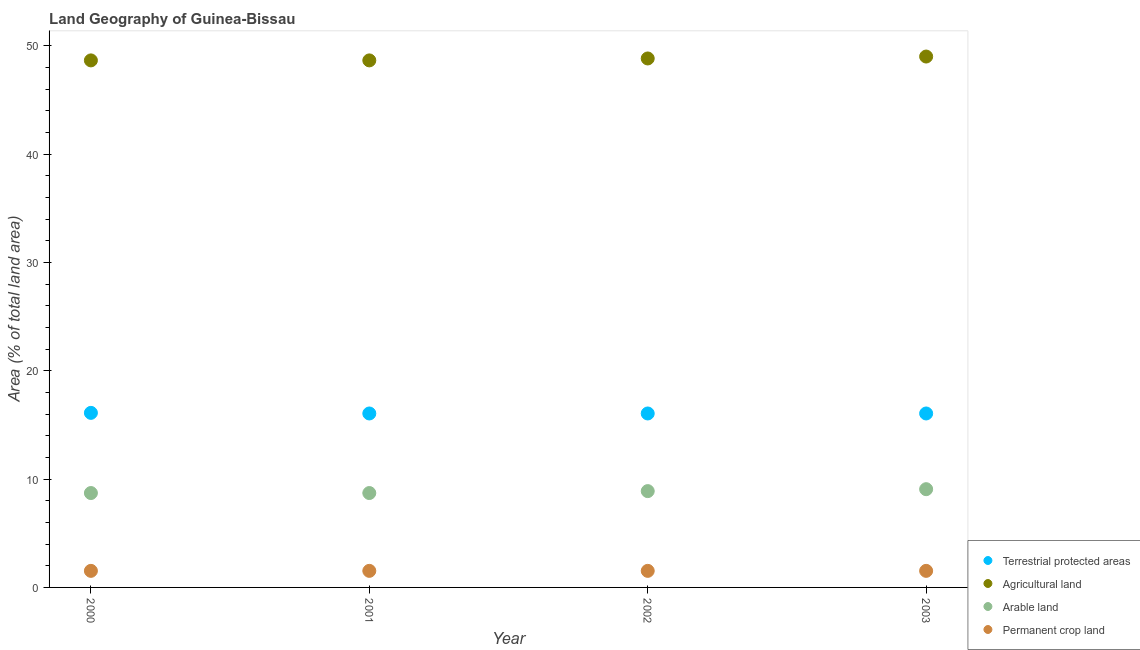How many different coloured dotlines are there?
Offer a very short reply. 4. Is the number of dotlines equal to the number of legend labels?
Provide a succinct answer. Yes. What is the percentage of area under agricultural land in 2001?
Provide a succinct answer. 48.65. Across all years, what is the maximum percentage of area under permanent crop land?
Your answer should be very brief. 1.53. Across all years, what is the minimum percentage of area under arable land?
Your answer should be very brief. 8.71. In which year was the percentage of area under arable land maximum?
Your answer should be very brief. 2003. What is the total percentage of area under permanent crop land in the graph?
Ensure brevity in your answer.  6.12. What is the difference between the percentage of area under arable land in 2001 and that in 2002?
Make the answer very short. -0.18. What is the difference between the percentage of land under terrestrial protection in 2001 and the percentage of area under agricultural land in 2000?
Your response must be concise. -32.59. What is the average percentage of land under terrestrial protection per year?
Offer a terse response. 16.07. In the year 2001, what is the difference between the percentage of area under arable land and percentage of land under terrestrial protection?
Provide a short and direct response. -7.34. In how many years, is the percentage of area under arable land greater than 34 %?
Offer a very short reply. 0. Is the percentage of area under agricultural land in 2000 less than that in 2001?
Ensure brevity in your answer.  No. What is the difference between the highest and the second highest percentage of area under agricultural land?
Provide a succinct answer. 0.18. What is the difference between the highest and the lowest percentage of land under terrestrial protection?
Provide a succinct answer. 0.06. Is it the case that in every year, the sum of the percentage of area under arable land and percentage of area under permanent crop land is greater than the sum of percentage of land under terrestrial protection and percentage of area under agricultural land?
Give a very brief answer. No. How many dotlines are there?
Ensure brevity in your answer.  4. Are the values on the major ticks of Y-axis written in scientific E-notation?
Ensure brevity in your answer.  No. Does the graph contain any zero values?
Give a very brief answer. No. How many legend labels are there?
Ensure brevity in your answer.  4. How are the legend labels stacked?
Your response must be concise. Vertical. What is the title of the graph?
Make the answer very short. Land Geography of Guinea-Bissau. Does "Taxes on exports" appear as one of the legend labels in the graph?
Provide a short and direct response. No. What is the label or title of the Y-axis?
Keep it short and to the point. Area (% of total land area). What is the Area (% of total land area) of Terrestrial protected areas in 2000?
Make the answer very short. 16.11. What is the Area (% of total land area) of Agricultural land in 2000?
Keep it short and to the point. 48.65. What is the Area (% of total land area) in Arable land in 2000?
Your answer should be very brief. 8.71. What is the Area (% of total land area) in Permanent crop land in 2000?
Your answer should be very brief. 1.53. What is the Area (% of total land area) in Terrestrial protected areas in 2001?
Offer a terse response. 16.06. What is the Area (% of total land area) of Agricultural land in 2001?
Ensure brevity in your answer.  48.65. What is the Area (% of total land area) in Arable land in 2001?
Your response must be concise. 8.71. What is the Area (% of total land area) in Permanent crop land in 2001?
Offer a very short reply. 1.53. What is the Area (% of total land area) of Terrestrial protected areas in 2002?
Offer a terse response. 16.06. What is the Area (% of total land area) of Agricultural land in 2002?
Your answer should be very brief. 48.83. What is the Area (% of total land area) in Arable land in 2002?
Ensure brevity in your answer.  8.89. What is the Area (% of total land area) of Permanent crop land in 2002?
Your answer should be very brief. 1.53. What is the Area (% of total land area) of Terrestrial protected areas in 2003?
Your response must be concise. 16.06. What is the Area (% of total land area) of Agricultural land in 2003?
Provide a short and direct response. 49. What is the Area (% of total land area) in Arable land in 2003?
Your response must be concise. 9.07. What is the Area (% of total land area) in Permanent crop land in 2003?
Keep it short and to the point. 1.53. Across all years, what is the maximum Area (% of total land area) of Terrestrial protected areas?
Keep it short and to the point. 16.11. Across all years, what is the maximum Area (% of total land area) of Agricultural land?
Make the answer very short. 49. Across all years, what is the maximum Area (% of total land area) in Arable land?
Offer a very short reply. 9.07. Across all years, what is the maximum Area (% of total land area) in Permanent crop land?
Give a very brief answer. 1.53. Across all years, what is the minimum Area (% of total land area) in Terrestrial protected areas?
Your answer should be compact. 16.06. Across all years, what is the minimum Area (% of total land area) in Agricultural land?
Keep it short and to the point. 48.65. Across all years, what is the minimum Area (% of total land area) of Arable land?
Keep it short and to the point. 8.71. Across all years, what is the minimum Area (% of total land area) of Permanent crop land?
Make the answer very short. 1.53. What is the total Area (% of total land area) in Terrestrial protected areas in the graph?
Make the answer very short. 64.28. What is the total Area (% of total land area) of Agricultural land in the graph?
Offer a terse response. 195.13. What is the total Area (% of total land area) of Arable land in the graph?
Your answer should be compact. 35.38. What is the total Area (% of total land area) of Permanent crop land in the graph?
Provide a short and direct response. 6.12. What is the difference between the Area (% of total land area) in Terrestrial protected areas in 2000 and that in 2001?
Offer a terse response. 0.06. What is the difference between the Area (% of total land area) of Agricultural land in 2000 and that in 2001?
Your answer should be compact. 0. What is the difference between the Area (% of total land area) in Arable land in 2000 and that in 2001?
Ensure brevity in your answer.  0. What is the difference between the Area (% of total land area) of Permanent crop land in 2000 and that in 2001?
Give a very brief answer. 0. What is the difference between the Area (% of total land area) in Terrestrial protected areas in 2000 and that in 2002?
Provide a succinct answer. 0.06. What is the difference between the Area (% of total land area) in Agricultural land in 2000 and that in 2002?
Provide a short and direct response. -0.18. What is the difference between the Area (% of total land area) in Arable land in 2000 and that in 2002?
Your answer should be very brief. -0.18. What is the difference between the Area (% of total land area) in Terrestrial protected areas in 2000 and that in 2003?
Your answer should be compact. 0.06. What is the difference between the Area (% of total land area) in Agricultural land in 2000 and that in 2003?
Give a very brief answer. -0.36. What is the difference between the Area (% of total land area) in Arable land in 2000 and that in 2003?
Give a very brief answer. -0.36. What is the difference between the Area (% of total land area) of Permanent crop land in 2000 and that in 2003?
Offer a terse response. 0. What is the difference between the Area (% of total land area) of Agricultural land in 2001 and that in 2002?
Offer a very short reply. -0.18. What is the difference between the Area (% of total land area) of Arable land in 2001 and that in 2002?
Give a very brief answer. -0.18. What is the difference between the Area (% of total land area) of Terrestrial protected areas in 2001 and that in 2003?
Offer a very short reply. 0. What is the difference between the Area (% of total land area) in Agricultural land in 2001 and that in 2003?
Make the answer very short. -0.36. What is the difference between the Area (% of total land area) of Arable land in 2001 and that in 2003?
Make the answer very short. -0.36. What is the difference between the Area (% of total land area) of Terrestrial protected areas in 2002 and that in 2003?
Your answer should be very brief. 0. What is the difference between the Area (% of total land area) of Agricultural land in 2002 and that in 2003?
Offer a terse response. -0.18. What is the difference between the Area (% of total land area) of Arable land in 2002 and that in 2003?
Make the answer very short. -0.18. What is the difference between the Area (% of total land area) in Terrestrial protected areas in 2000 and the Area (% of total land area) in Agricultural land in 2001?
Offer a terse response. -32.54. What is the difference between the Area (% of total land area) in Terrestrial protected areas in 2000 and the Area (% of total land area) in Arable land in 2001?
Offer a terse response. 7.4. What is the difference between the Area (% of total land area) in Terrestrial protected areas in 2000 and the Area (% of total land area) in Permanent crop land in 2001?
Offer a terse response. 14.58. What is the difference between the Area (% of total land area) of Agricultural land in 2000 and the Area (% of total land area) of Arable land in 2001?
Keep it short and to the point. 39.94. What is the difference between the Area (% of total land area) in Agricultural land in 2000 and the Area (% of total land area) in Permanent crop land in 2001?
Make the answer very short. 47.12. What is the difference between the Area (% of total land area) of Arable land in 2000 and the Area (% of total land area) of Permanent crop land in 2001?
Your answer should be compact. 7.18. What is the difference between the Area (% of total land area) of Terrestrial protected areas in 2000 and the Area (% of total land area) of Agricultural land in 2002?
Provide a short and direct response. -32.71. What is the difference between the Area (% of total land area) of Terrestrial protected areas in 2000 and the Area (% of total land area) of Arable land in 2002?
Provide a short and direct response. 7.22. What is the difference between the Area (% of total land area) of Terrestrial protected areas in 2000 and the Area (% of total land area) of Permanent crop land in 2002?
Offer a terse response. 14.58. What is the difference between the Area (% of total land area) of Agricultural land in 2000 and the Area (% of total land area) of Arable land in 2002?
Your response must be concise. 39.76. What is the difference between the Area (% of total land area) in Agricultural land in 2000 and the Area (% of total land area) in Permanent crop land in 2002?
Offer a very short reply. 47.12. What is the difference between the Area (% of total land area) of Arable land in 2000 and the Area (% of total land area) of Permanent crop land in 2002?
Keep it short and to the point. 7.18. What is the difference between the Area (% of total land area) in Terrestrial protected areas in 2000 and the Area (% of total land area) in Agricultural land in 2003?
Offer a very short reply. -32.89. What is the difference between the Area (% of total land area) in Terrestrial protected areas in 2000 and the Area (% of total land area) in Arable land in 2003?
Keep it short and to the point. 7.04. What is the difference between the Area (% of total land area) in Terrestrial protected areas in 2000 and the Area (% of total land area) in Permanent crop land in 2003?
Your answer should be compact. 14.58. What is the difference between the Area (% of total land area) of Agricultural land in 2000 and the Area (% of total land area) of Arable land in 2003?
Offer a very short reply. 39.58. What is the difference between the Area (% of total land area) in Agricultural land in 2000 and the Area (% of total land area) in Permanent crop land in 2003?
Your answer should be compact. 47.12. What is the difference between the Area (% of total land area) of Arable land in 2000 and the Area (% of total land area) of Permanent crop land in 2003?
Keep it short and to the point. 7.18. What is the difference between the Area (% of total land area) of Terrestrial protected areas in 2001 and the Area (% of total land area) of Agricultural land in 2002?
Give a very brief answer. -32.77. What is the difference between the Area (% of total land area) in Terrestrial protected areas in 2001 and the Area (% of total land area) in Arable land in 2002?
Ensure brevity in your answer.  7.17. What is the difference between the Area (% of total land area) in Terrestrial protected areas in 2001 and the Area (% of total land area) in Permanent crop land in 2002?
Offer a very short reply. 14.53. What is the difference between the Area (% of total land area) in Agricultural land in 2001 and the Area (% of total land area) in Arable land in 2002?
Keep it short and to the point. 39.76. What is the difference between the Area (% of total land area) of Agricultural land in 2001 and the Area (% of total land area) of Permanent crop land in 2002?
Offer a terse response. 47.12. What is the difference between the Area (% of total land area) in Arable land in 2001 and the Area (% of total land area) in Permanent crop land in 2002?
Keep it short and to the point. 7.18. What is the difference between the Area (% of total land area) in Terrestrial protected areas in 2001 and the Area (% of total land area) in Agricultural land in 2003?
Your answer should be very brief. -32.95. What is the difference between the Area (% of total land area) of Terrestrial protected areas in 2001 and the Area (% of total land area) of Arable land in 2003?
Ensure brevity in your answer.  6.99. What is the difference between the Area (% of total land area) of Terrestrial protected areas in 2001 and the Area (% of total land area) of Permanent crop land in 2003?
Your answer should be compact. 14.53. What is the difference between the Area (% of total land area) in Agricultural land in 2001 and the Area (% of total land area) in Arable land in 2003?
Offer a terse response. 39.58. What is the difference between the Area (% of total land area) in Agricultural land in 2001 and the Area (% of total land area) in Permanent crop land in 2003?
Make the answer very short. 47.12. What is the difference between the Area (% of total land area) in Arable land in 2001 and the Area (% of total land area) in Permanent crop land in 2003?
Provide a succinct answer. 7.18. What is the difference between the Area (% of total land area) in Terrestrial protected areas in 2002 and the Area (% of total land area) in Agricultural land in 2003?
Make the answer very short. -32.95. What is the difference between the Area (% of total land area) in Terrestrial protected areas in 2002 and the Area (% of total land area) in Arable land in 2003?
Keep it short and to the point. 6.99. What is the difference between the Area (% of total land area) in Terrestrial protected areas in 2002 and the Area (% of total land area) in Permanent crop land in 2003?
Your answer should be very brief. 14.53. What is the difference between the Area (% of total land area) in Agricultural land in 2002 and the Area (% of total land area) in Arable land in 2003?
Offer a very short reply. 39.76. What is the difference between the Area (% of total land area) of Agricultural land in 2002 and the Area (% of total land area) of Permanent crop land in 2003?
Ensure brevity in your answer.  47.3. What is the difference between the Area (% of total land area) in Arable land in 2002 and the Area (% of total land area) in Permanent crop land in 2003?
Make the answer very short. 7.36. What is the average Area (% of total land area) of Terrestrial protected areas per year?
Your answer should be very brief. 16.07. What is the average Area (% of total land area) of Agricultural land per year?
Your response must be concise. 48.78. What is the average Area (% of total land area) in Arable land per year?
Your answer should be compact. 8.85. What is the average Area (% of total land area) in Permanent crop land per year?
Offer a terse response. 1.53. In the year 2000, what is the difference between the Area (% of total land area) of Terrestrial protected areas and Area (% of total land area) of Agricultural land?
Give a very brief answer. -32.54. In the year 2000, what is the difference between the Area (% of total land area) of Terrestrial protected areas and Area (% of total land area) of Arable land?
Keep it short and to the point. 7.4. In the year 2000, what is the difference between the Area (% of total land area) of Terrestrial protected areas and Area (% of total land area) of Permanent crop land?
Your answer should be compact. 14.58. In the year 2000, what is the difference between the Area (% of total land area) in Agricultural land and Area (% of total land area) in Arable land?
Offer a terse response. 39.94. In the year 2000, what is the difference between the Area (% of total land area) in Agricultural land and Area (% of total land area) in Permanent crop land?
Make the answer very short. 47.12. In the year 2000, what is the difference between the Area (% of total land area) in Arable land and Area (% of total land area) in Permanent crop land?
Offer a very short reply. 7.18. In the year 2001, what is the difference between the Area (% of total land area) of Terrestrial protected areas and Area (% of total land area) of Agricultural land?
Keep it short and to the point. -32.59. In the year 2001, what is the difference between the Area (% of total land area) in Terrestrial protected areas and Area (% of total land area) in Arable land?
Offer a very short reply. 7.34. In the year 2001, what is the difference between the Area (% of total land area) of Terrestrial protected areas and Area (% of total land area) of Permanent crop land?
Keep it short and to the point. 14.53. In the year 2001, what is the difference between the Area (% of total land area) in Agricultural land and Area (% of total land area) in Arable land?
Keep it short and to the point. 39.94. In the year 2001, what is the difference between the Area (% of total land area) in Agricultural land and Area (% of total land area) in Permanent crop land?
Make the answer very short. 47.12. In the year 2001, what is the difference between the Area (% of total land area) in Arable land and Area (% of total land area) in Permanent crop land?
Make the answer very short. 7.18. In the year 2002, what is the difference between the Area (% of total land area) in Terrestrial protected areas and Area (% of total land area) in Agricultural land?
Provide a succinct answer. -32.77. In the year 2002, what is the difference between the Area (% of total land area) in Terrestrial protected areas and Area (% of total land area) in Arable land?
Offer a very short reply. 7.17. In the year 2002, what is the difference between the Area (% of total land area) in Terrestrial protected areas and Area (% of total land area) in Permanent crop land?
Provide a succinct answer. 14.53. In the year 2002, what is the difference between the Area (% of total land area) in Agricultural land and Area (% of total land area) in Arable land?
Offer a terse response. 39.94. In the year 2002, what is the difference between the Area (% of total land area) in Agricultural land and Area (% of total land area) in Permanent crop land?
Make the answer very short. 47.3. In the year 2002, what is the difference between the Area (% of total land area) in Arable land and Area (% of total land area) in Permanent crop land?
Your answer should be compact. 7.36. In the year 2003, what is the difference between the Area (% of total land area) in Terrestrial protected areas and Area (% of total land area) in Agricultural land?
Offer a very short reply. -32.95. In the year 2003, what is the difference between the Area (% of total land area) of Terrestrial protected areas and Area (% of total land area) of Arable land?
Offer a very short reply. 6.99. In the year 2003, what is the difference between the Area (% of total land area) of Terrestrial protected areas and Area (% of total land area) of Permanent crop land?
Your response must be concise. 14.53. In the year 2003, what is the difference between the Area (% of total land area) in Agricultural land and Area (% of total land area) in Arable land?
Keep it short and to the point. 39.94. In the year 2003, what is the difference between the Area (% of total land area) of Agricultural land and Area (% of total land area) of Permanent crop land?
Your response must be concise. 47.48. In the year 2003, what is the difference between the Area (% of total land area) in Arable land and Area (% of total land area) in Permanent crop land?
Your response must be concise. 7.54. What is the ratio of the Area (% of total land area) of Terrestrial protected areas in 2000 to that in 2001?
Your response must be concise. 1. What is the ratio of the Area (% of total land area) of Agricultural land in 2000 to that in 2001?
Your answer should be very brief. 1. What is the ratio of the Area (% of total land area) of Terrestrial protected areas in 2000 to that in 2003?
Offer a very short reply. 1. What is the ratio of the Area (% of total land area) in Agricultural land in 2000 to that in 2003?
Provide a succinct answer. 0.99. What is the ratio of the Area (% of total land area) in Arable land in 2000 to that in 2003?
Offer a very short reply. 0.96. What is the ratio of the Area (% of total land area) of Permanent crop land in 2000 to that in 2003?
Offer a very short reply. 1. What is the ratio of the Area (% of total land area) in Terrestrial protected areas in 2001 to that in 2002?
Offer a terse response. 1. What is the ratio of the Area (% of total land area) of Arable land in 2001 to that in 2003?
Provide a succinct answer. 0.96. What is the ratio of the Area (% of total land area) in Agricultural land in 2002 to that in 2003?
Provide a short and direct response. 1. What is the ratio of the Area (% of total land area) in Arable land in 2002 to that in 2003?
Give a very brief answer. 0.98. What is the ratio of the Area (% of total land area) of Permanent crop land in 2002 to that in 2003?
Keep it short and to the point. 1. What is the difference between the highest and the second highest Area (% of total land area) of Terrestrial protected areas?
Offer a very short reply. 0.06. What is the difference between the highest and the second highest Area (% of total land area) in Agricultural land?
Make the answer very short. 0.18. What is the difference between the highest and the second highest Area (% of total land area) of Arable land?
Keep it short and to the point. 0.18. What is the difference between the highest and the lowest Area (% of total land area) in Terrestrial protected areas?
Ensure brevity in your answer.  0.06. What is the difference between the highest and the lowest Area (% of total land area) of Agricultural land?
Your answer should be compact. 0.36. What is the difference between the highest and the lowest Area (% of total land area) in Arable land?
Ensure brevity in your answer.  0.36. 